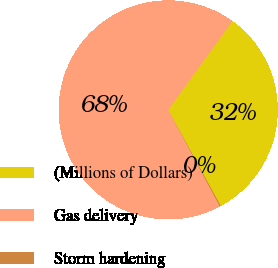Convert chart to OTSL. <chart><loc_0><loc_0><loc_500><loc_500><pie_chart><fcel>(Millions of Dollars)<fcel>Gas delivery<fcel>Storm hardening<nl><fcel>32.08%<fcel>67.79%<fcel>0.13%<nl></chart> 